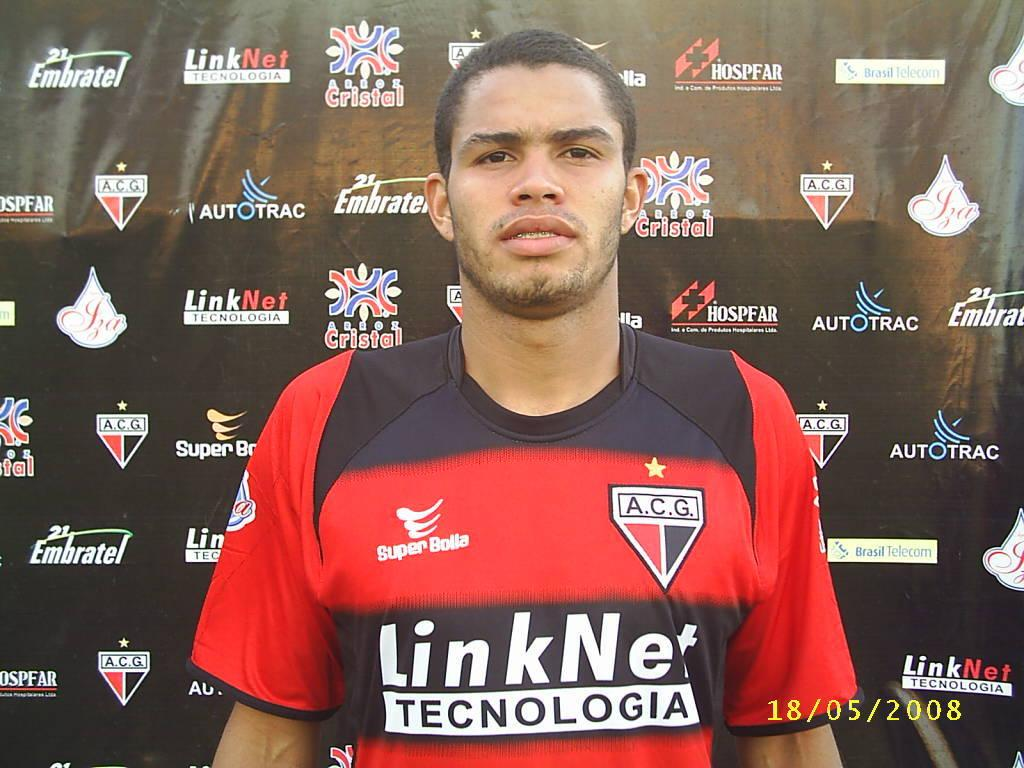Provide a one-sentence caption for the provided image. The sponsor of the jersey was the LinkNet company. 